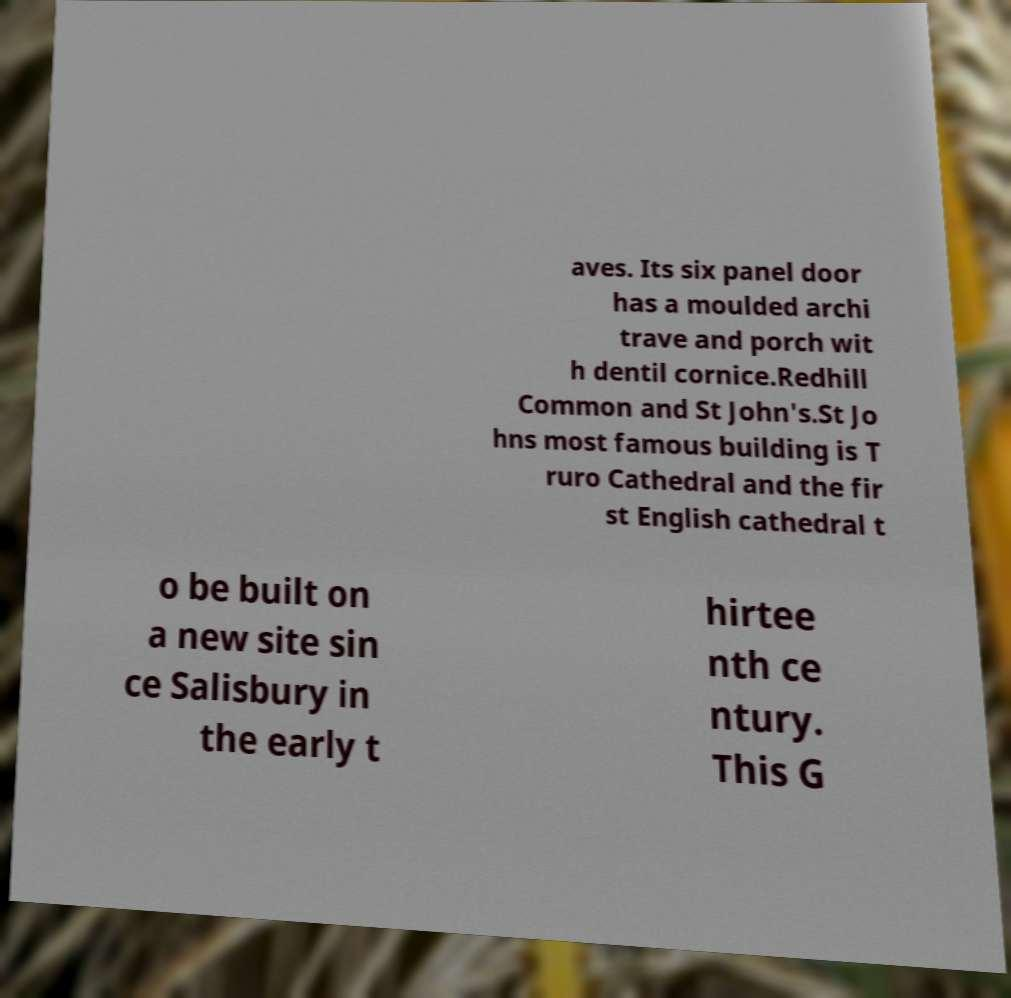What messages or text are displayed in this image? I need them in a readable, typed format. aves. Its six panel door has a moulded archi trave and porch wit h dentil cornice.Redhill Common and St John's.St Jo hns most famous building is T ruro Cathedral and the fir st English cathedral t o be built on a new site sin ce Salisbury in the early t hirtee nth ce ntury. This G 